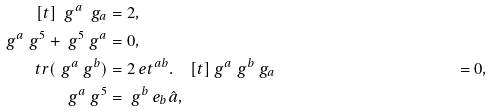<formula> <loc_0><loc_0><loc_500><loc_500>[ t ] \ g ^ { a } \ g _ { a } & = 2 , \\ \ g ^ { a } \ g ^ { 5 } + \ g ^ { 5 } \ g ^ { a } & = 0 , \\ \ t r ( \ g ^ { a } \ g ^ { b } ) & = 2 \ e t ^ { a b } . \quad [ t ] \ g ^ { a } \ g ^ { b } \ g _ { a } & = 0 , \\ \ g ^ { a } \ g ^ { 5 } & = \ g ^ { b } \ e _ { b } \hat { a } ,</formula> 